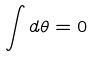Convert formula to latex. <formula><loc_0><loc_0><loc_500><loc_500>\int d \theta = 0</formula> 